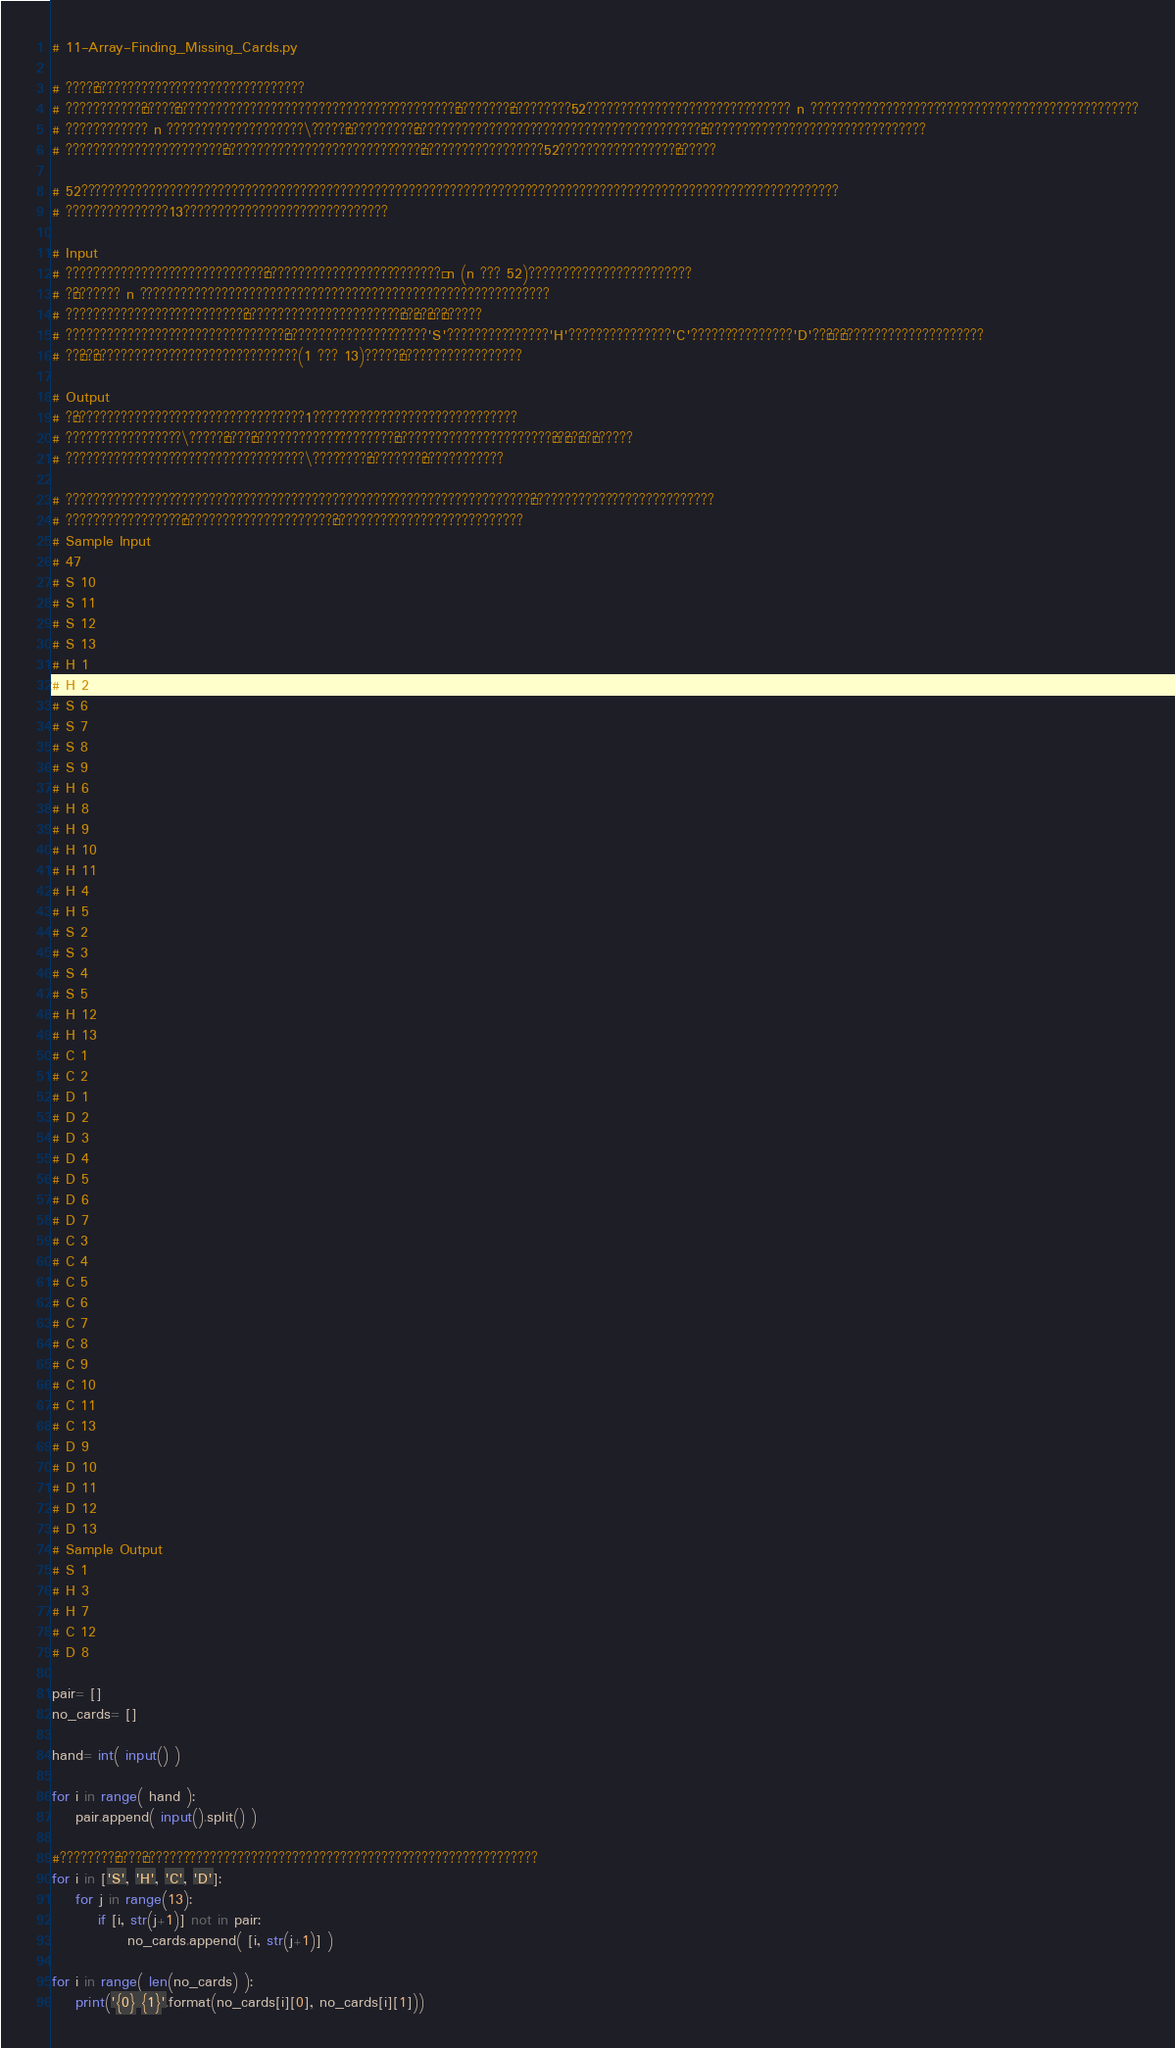Convert code to text. <code><loc_0><loc_0><loc_500><loc_500><_Python_># 11-Array-Finding_Missing_Cards.py

# ????¶???????????????????????????????
# ???????????±?????¨?????????????????????????????????????????¨????????¨?????????52?????????????????????????????? n ????????????????????????????????????????????????
# ???????????? n ????????????????????\?????¨??????????¶??????????????????????????????????????????°?????????????????????????????????
# ???????????????????????£?????????????????????????????§??????????????????52?????????????????§??????

# 52???????????????????????????????????????????????????????????????????????????????????????????????????????????????
# ???????????????13??????????????????????????????

# Input
# ?????????????????????????????£??????????????????????????° n (n ??? 52)????????????????????????
# ?¶??????? n ????????????????????????????????????????????????????????????
# ??????????????????????????§???????????????????????¨??´??°??§??????
# ????????????????????????????????¨?????????????????????'S'???????????????'H'???????????????'C'???????????????'D'??§??¨?????????????????????
# ??´??°??????????????????????????????(1 ??? 13)?????¨??????????????????

# Output
# ?¶??????????????????????????????????1??????????????????????????????
# ?????????????????\?????¨????§?????????????????????§???????????????????????¨??´??°??§??????
# ???????????????????????????????????\????????¨????????¨????????????

# ????????????????????????????????????????????????????????????????????§???????????????????????????
# ?????????????????´??????????????????????°????????????????????????????
# Sample Input
# 47
# S 10
# S 11
# S 12
# S 13
# H 1
# H 2
# S 6
# S 7
# S 8
# S 9
# H 6
# H 8
# H 9
# H 10
# H 11
# H 4
# H 5
# S 2
# S 3
# S 4
# S 5
# H 12
# H 13
# C 1
# C 2
# D 1
# D 2
# D 3
# D 4
# D 5
# D 6
# D 7
# C 3
# C 4
# C 5
# C 6
# C 7
# C 8
# C 9
# C 10
# C 11
# C 13
# D 9
# D 10
# D 11
# D 12
# D 13
# Sample Output
# S 1
# H 3
# H 7
# C 12
# D 8

pair= []
no_cards= []

hand= int( input() )

for i in range( hand ):
	pair.append( input().split() )

#????????§????¶??????????????????????????????????????????????????????????
for i in ['S', 'H', 'C', 'D']:
	for j in range(13):
		if [i, str(j+1)] not in pair:
			 no_cards.append( [i, str(j+1)] ) 

for i in range( len(no_cards) ):
	print('{0} {1}'.format(no_cards[i][0], no_cards[i][1]))</code> 